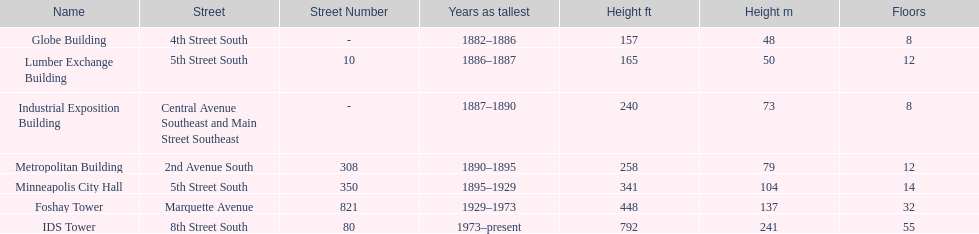How many floors does the foshay tower have? 32. 